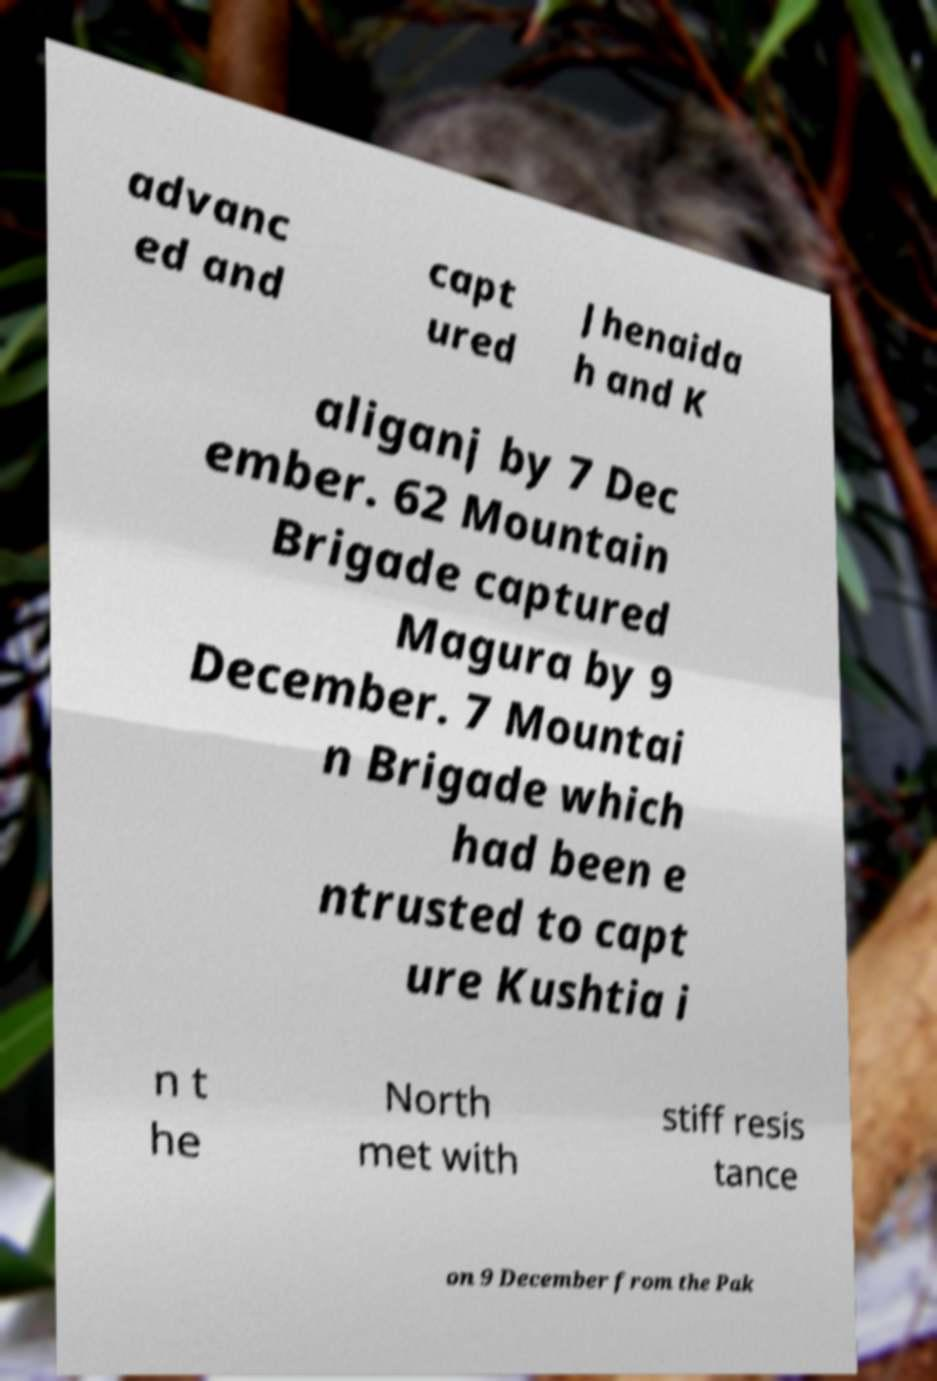There's text embedded in this image that I need extracted. Can you transcribe it verbatim? advanc ed and capt ured Jhenaida h and K aliganj by 7 Dec ember. 62 Mountain Brigade captured Magura by 9 December. 7 Mountai n Brigade which had been e ntrusted to capt ure Kushtia i n t he North met with stiff resis tance on 9 December from the Pak 